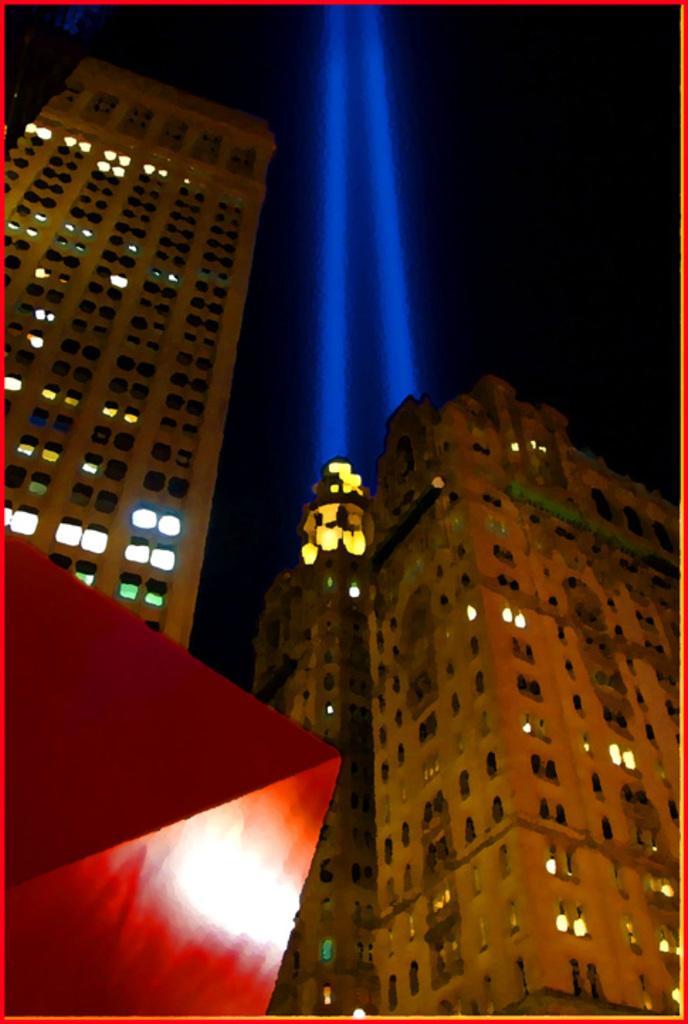In one or two sentences, can you explain what this image depicts? This is an image clicked in the dark. In this image, I can see few buildings along with the lights. At the top of the building there are two blue color lights. In the bottom left there is a red color object. 